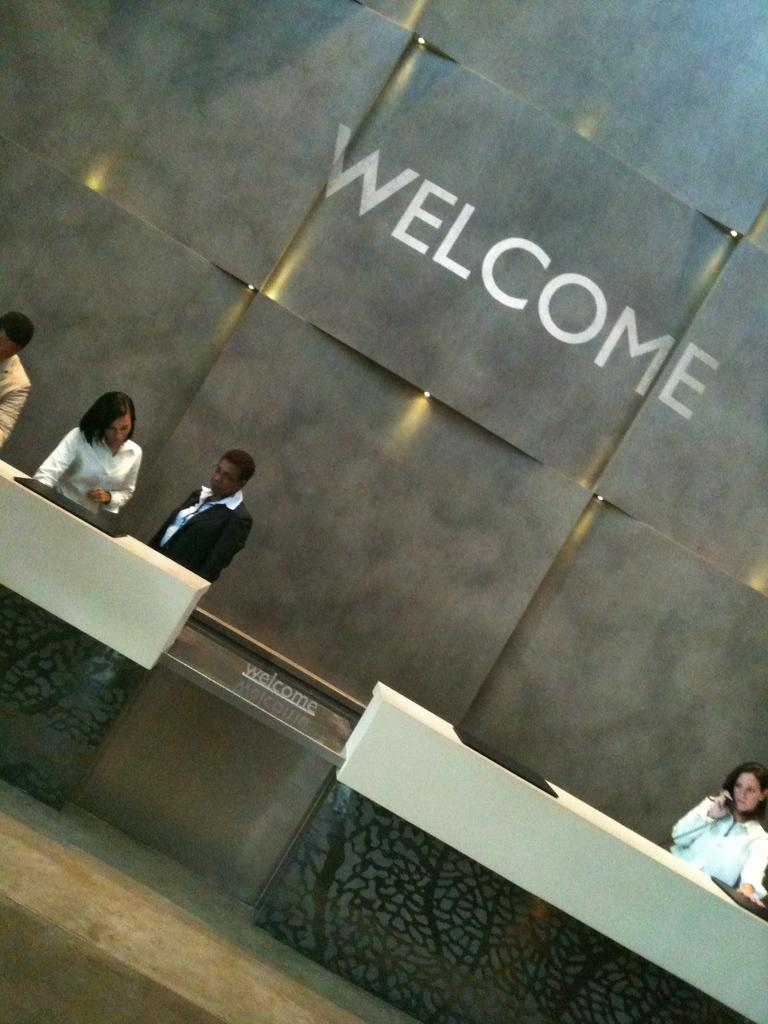What is happening in the image? There are people standing in the image. Can you describe the actions of one of the people? There is a person holding a telephone in the image. On which side of the image is the person holding the telephone? The person holding the telephone is on the right side of the image. What can be seen in the background of the image? There is text written on a wall in the background of the image. What type of tools is the carpenter using in the image? There is no carpenter or tools present in the image. How is the distribution of people arranged in the image? The image does not provide information about the distribution of people; it only shows that there are people standing. 